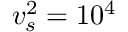<formula> <loc_0><loc_0><loc_500><loc_500>v _ { s } ^ { 2 } = 1 0 ^ { 4 }</formula> 